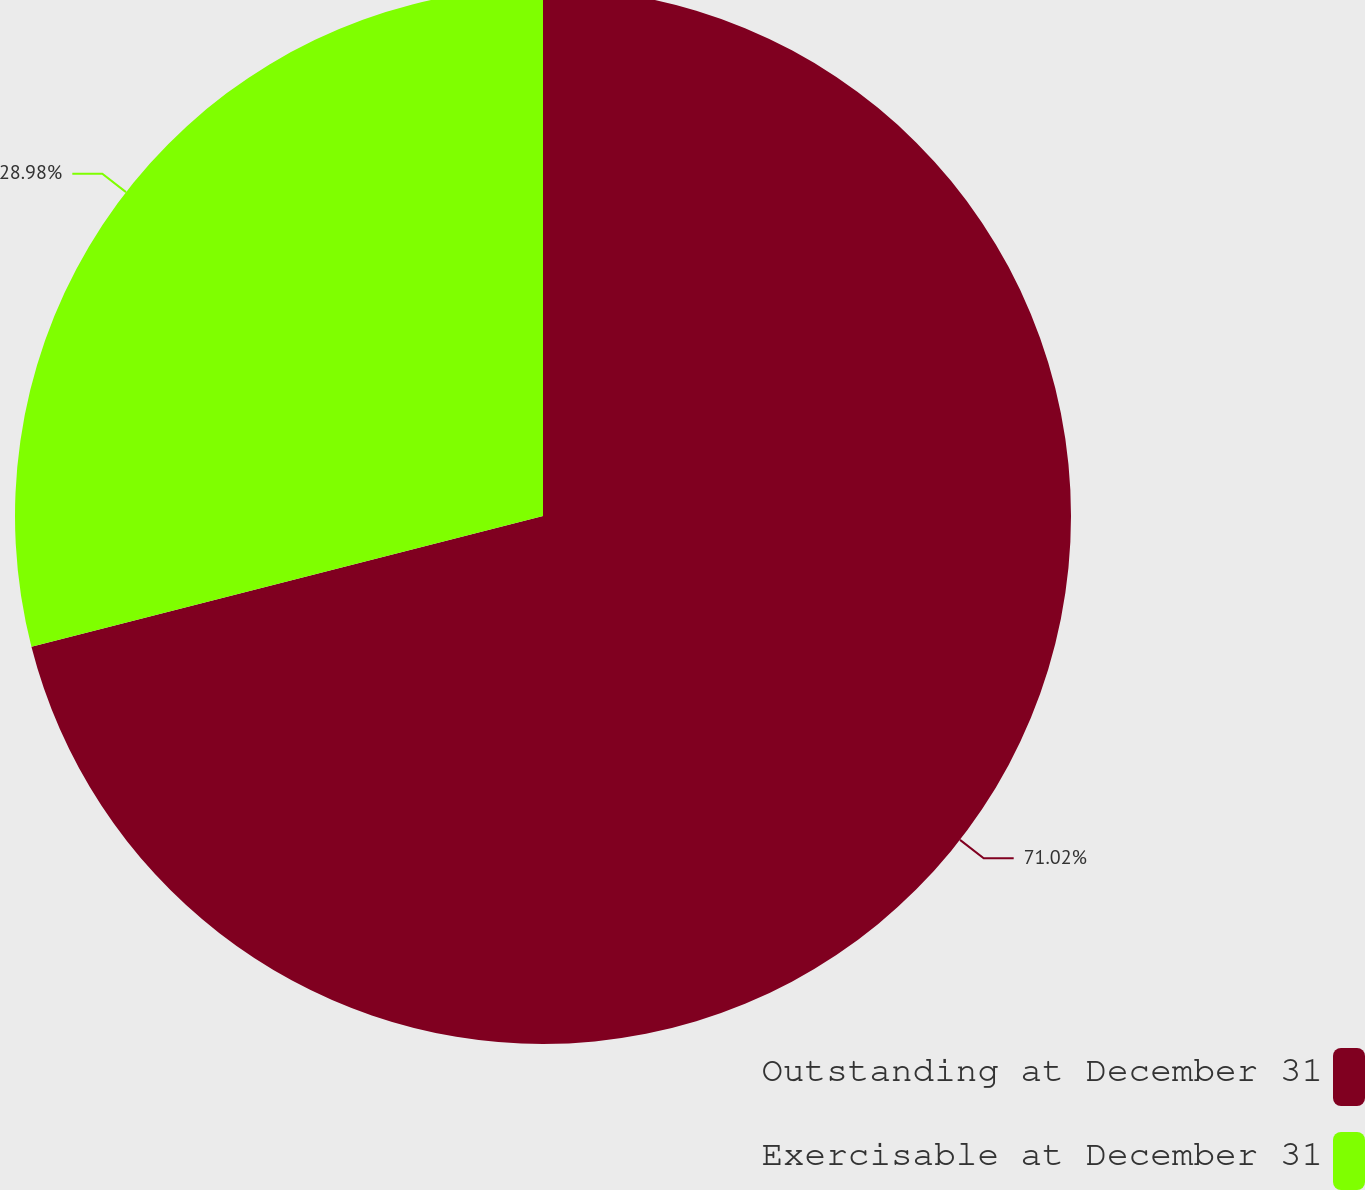Convert chart. <chart><loc_0><loc_0><loc_500><loc_500><pie_chart><fcel>Outstanding at December 31<fcel>Exercisable at December 31<nl><fcel>71.02%<fcel>28.98%<nl></chart> 